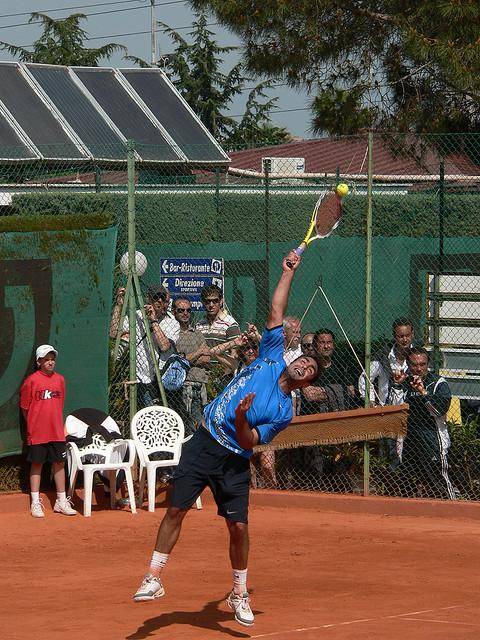Why is his arm so high in the air?

Choices:
A) unbalanced
B) hit ball
C) wants attention
D) arm broken hit ball 